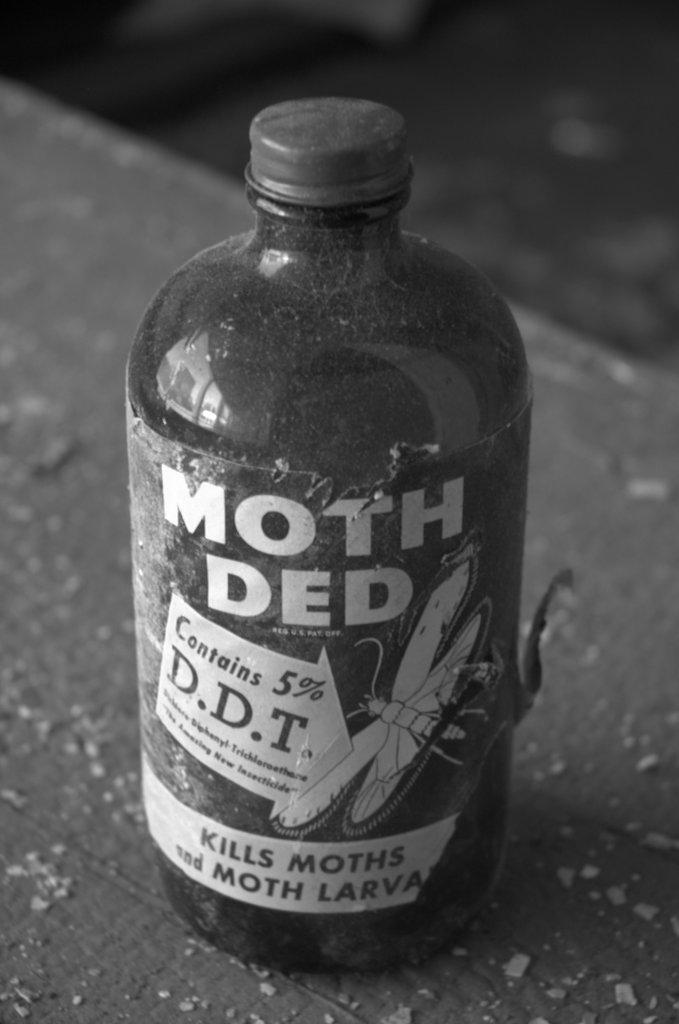<image>
Write a terse but informative summary of the picture. A bottle of Moth Ded that kills moths and moth larva and contains DDT. 